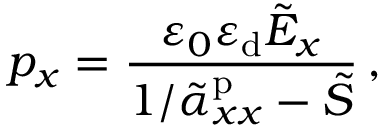Convert formula to latex. <formula><loc_0><loc_0><loc_500><loc_500>p _ { x } = \frac { \varepsilon _ { 0 } \varepsilon _ { d } \tilde { E } _ { x } } { 1 / \tilde { \alpha } _ { x x } ^ { p } - \tilde { S } } \, ,</formula> 